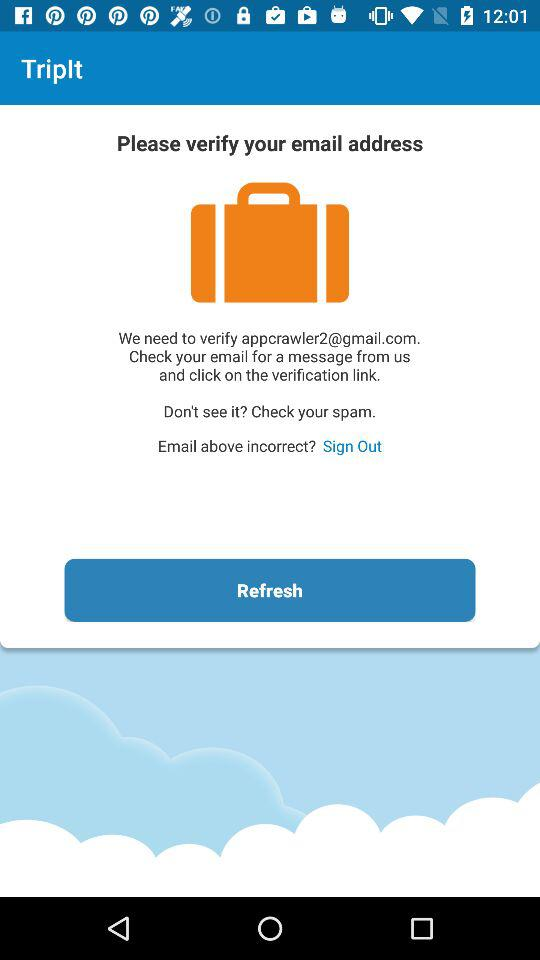What is the application name? The application name is "TripIt". 